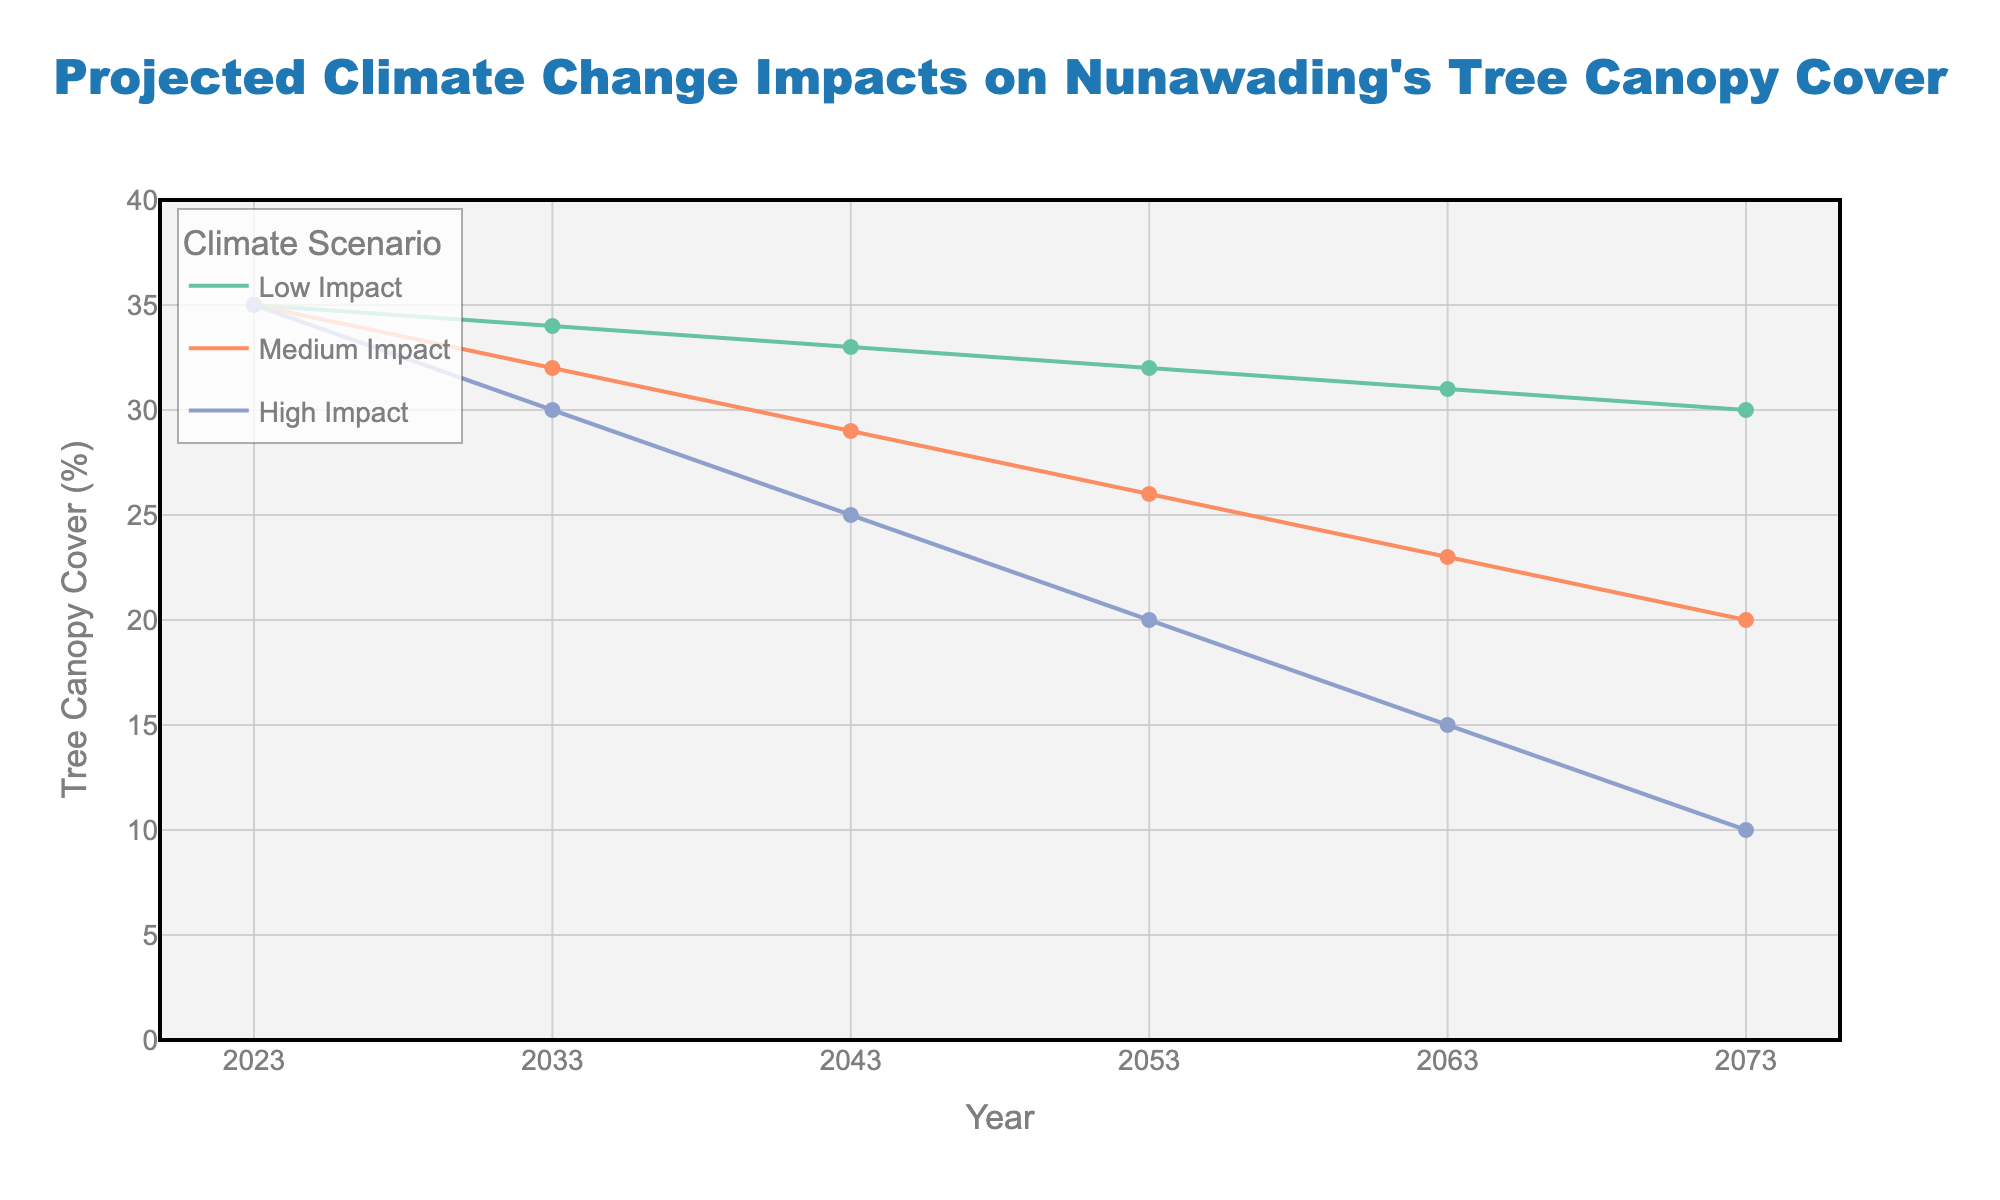What is the title of the figure? The title is located at the top of the figure and reads as "Projected Climate Change Impacts on Nunawading's Tree Canopy Cover"
Answer: Projected Climate Change Impacts on Nunawading's Tree Canopy Cover How many years does the projection cover? The X-axis shows the years from 2023 to 2073, which covers 50 years
Answer: 50 years Which climate scenario shows the greatest decrease in tree canopy cover by 2073? The legend on the right side of the figure shows three climate scenarios: Low Impact, Medium Impact, and High Impact. By looking at the Y-values for 2073, it's clear that the High Impact scenario shows the greatest decrease, going down to 10%
Answer: High Impact What was the tree canopy cover percentage in 2023 for all scenarios? By looking at the starting point (2023) on the Y-axis, all three scenarios (Low Impact, Medium Impact, and High Impact) have the same tree canopy cover of 35%
Answer: 35% How much does the tree canopy cover percentage in the Low Impact scenario change from 2023 to 2073? Initially, the tree canopy cover for the Low Impact scenario is 35% in 2023. By 2073, it falls to 30%. The change is calculated as 35% - 30% = 5%
Answer: 5% What is the average tree canopy cover percentage in 2033 across all scenarios? For 2033, the tree canopy cover percentages are 34% (Low Impact), 32% (Medium Impact), and 30% (High Impact). The average is (34 + 32 + 30) / 3 = 32%
Answer: 32% Which scenario shows a tree canopy cover of 25% and in what year? By examining the Y-values, we find that the High Impact scenario shows a tree canopy cover of 25% in 2043
Answer: High Impact, 2043 How does the tree canopy cover in the Medium Impact scenario compare between 2053 and 2073? In 2053, the tree canopy cover for the Medium Impact scenario is 26%. In 2073, it is 20%. The difference is 26% - 20% = 6%
Answer: 6% By how many degrees Celsius is the temperature projected to increase in the High Impact scenario by 2073? The data indicates that by 2073, the temperature increase is 6°C in the High Impact scenario, as stated in the provided table
Answer: 6°C Which climate scenario has the most stable tree canopy cover percentage over the years? By observing the lines' slopes, the Low Impact scenario's tree canopy cover decreases steadily but less steeply compared to Medium and High Impact scenarios, indicating it is the most stable over time
Answer: Low Impact 